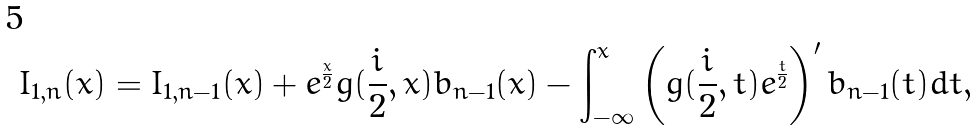<formula> <loc_0><loc_0><loc_500><loc_500>I _ { 1 , n } ( x ) = I _ { 1 , n - 1 } ( x ) + e ^ { \frac { x } { 2 } } g ( \frac { i } { 2 } , x ) b _ { n - 1 } ( x ) - \int _ { - \infty } ^ { x } \left ( g ( \frac { i } { 2 } , t ) e ^ { \frac { t } { 2 } } \right ) ^ { \prime } b _ { n - 1 } ( t ) d t ,</formula> 